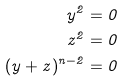Convert formula to latex. <formula><loc_0><loc_0><loc_500><loc_500>y ^ { 2 } = 0 \\ z ^ { 2 } = 0 \\ ( y + z ) ^ { n - 2 } = 0</formula> 